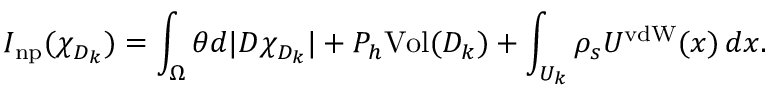Convert formula to latex. <formula><loc_0><loc_0><loc_500><loc_500>I _ { n p } ( \chi _ { D _ { k } } ) = \int _ { \Omega } \theta d | D \chi _ { D _ { k } } | + P _ { h } V o l ( D _ { k } ) + \int _ { U _ { k } } \rho _ { s } U ^ { v d W } ( x ) \, d x .</formula> 